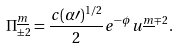<formula> <loc_0><loc_0><loc_500><loc_500>\Pi _ { \pm 2 } ^ { \underline { m } } = \frac { c ( \alpha \prime ) ^ { 1 / 2 } } { 2 } e ^ { - \phi } u ^ { \underline { m } \mp 2 } .</formula> 